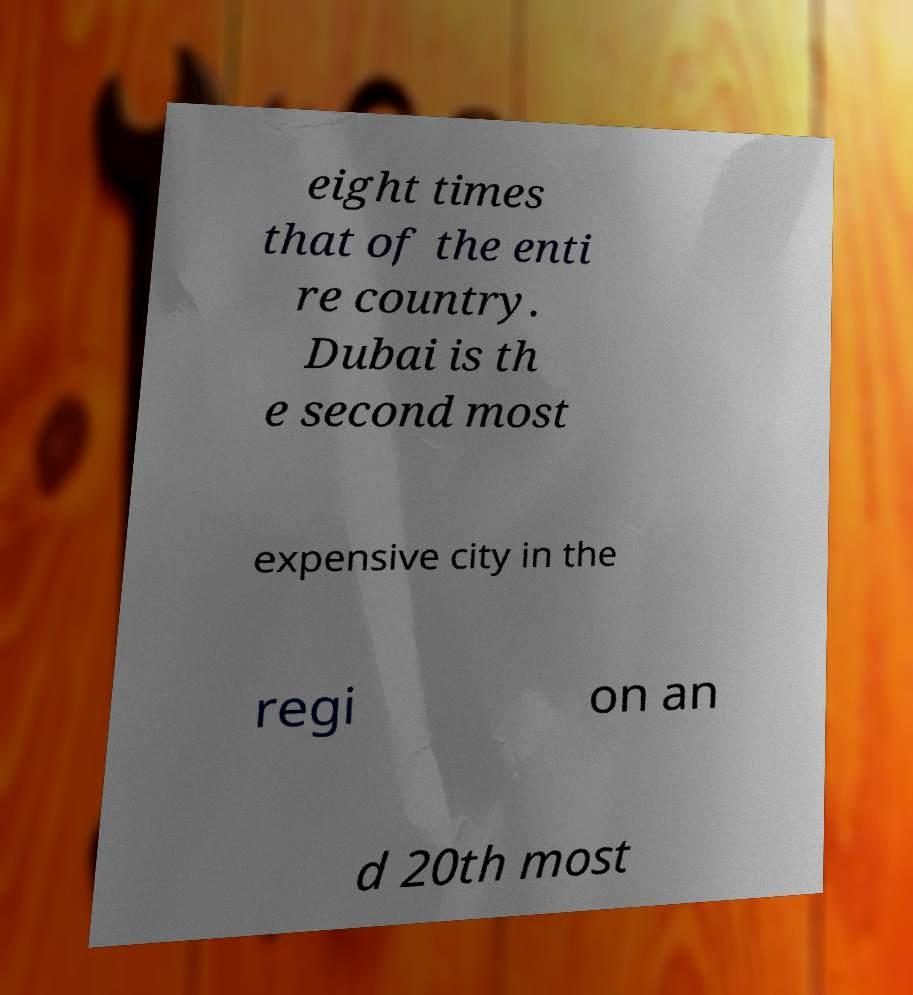Could you assist in decoding the text presented in this image and type it out clearly? eight times that of the enti re country. Dubai is th e second most expensive city in the regi on an d 20th most 